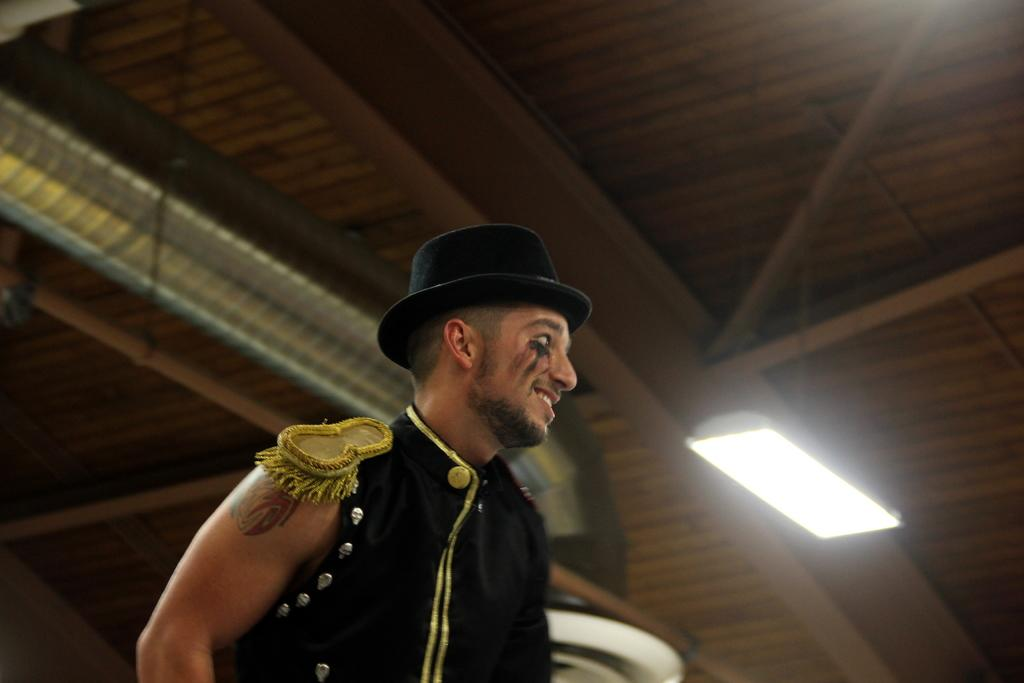Who is present in the image? There is a man in the image. What is the man wearing? The man is wearing a black dress and a hat. What can be seen in the background of the image? There is a roof and light visible in the background of the image. What type of pin can be seen on the man's hat in the image? There is no pin visible on the man's hat in the image. What design is featured on the turkey in the image? There is no turkey present in the image. 